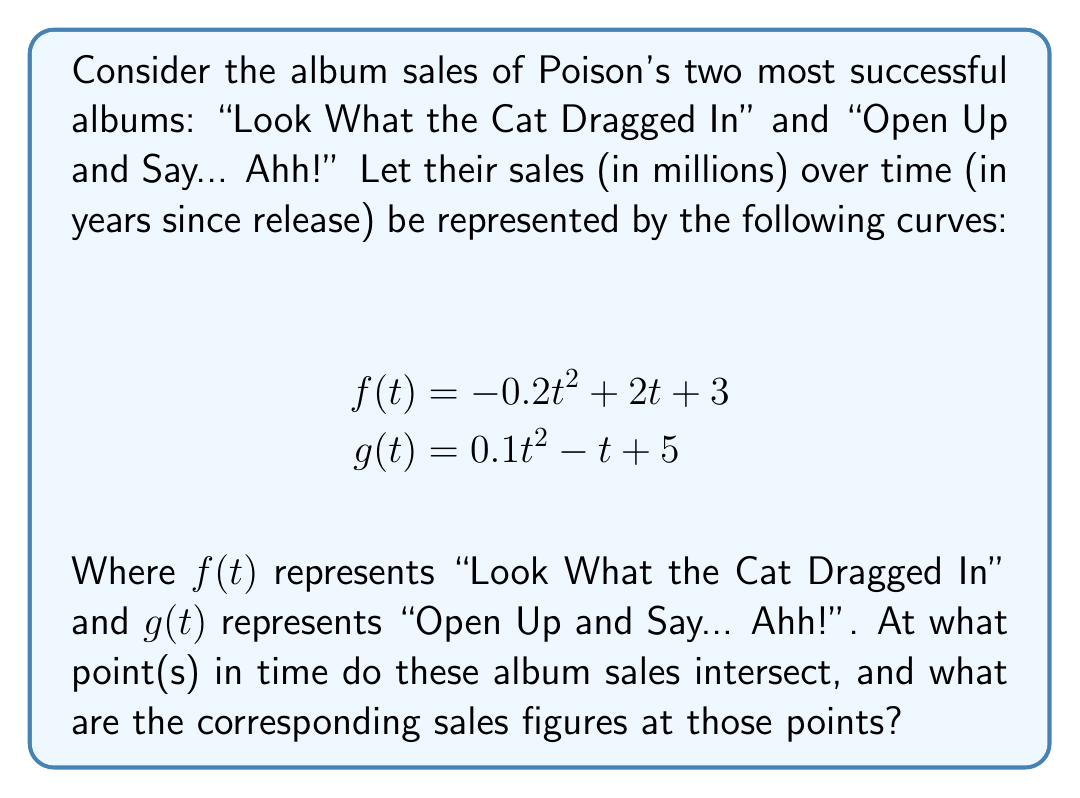Teach me how to tackle this problem. To find the intersection points of these curves, we need to solve the equation $f(t) = g(t)$:

1) Set up the equation:
   $$-0.2t^2 + 2t + 3 = 0.1t^2 - t + 5$$

2) Rearrange all terms to one side:
   $$-0.3t^2 + 3t - 2 = 0$$

3) This is a quadratic equation in the form $at^2 + bt + c = 0$, where:
   $a = -0.3$, $b = 3$, and $c = -2$

4) Use the quadratic formula: $t = \frac{-b \pm \sqrt{b^2 - 4ac}}{2a}$

5) Substitute the values:
   $$t = \frac{-3 \pm \sqrt{3^2 - 4(-0.3)(-2)}}{2(-0.3)}$$

6) Simplify:
   $$t = \frac{-3 \pm \sqrt{9 - 2.4}}{-0.6} = \frac{-3 \pm \sqrt{6.6}}{-0.6}$$

7) Calculate the two solutions:
   $$t_1 = \frac{-3 + \sqrt{6.6}}{-0.6} \approx 0.8541$$
   $$t_2 = \frac{-3 - \sqrt{6.6}}{-0.6} \approx 7.8126$$

8) To find the sales figures at these points, substitute either $t_1$ or $t_2$ into $f(t)$ or $g(t)$:
   $$f(0.8541) \approx g(0.8541) \approx 4.5645$$ (million albums)
   $$f(7.8126) \approx g(7.8126) \approx 1.7721$$ (million albums)

Therefore, the album sales intersect at approximately 0.8541 and 7.8126 years after release, with sales of about 4.5645 million and 1.7721 million albums respectively.
Answer: (0.8541, 4.5645) and (7.8126, 1.7721) 